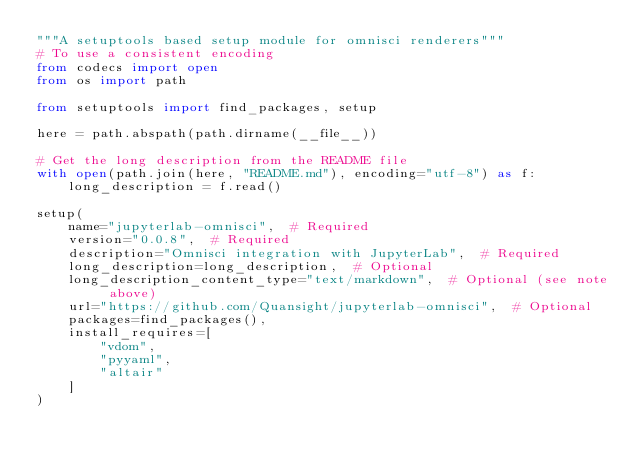Convert code to text. <code><loc_0><loc_0><loc_500><loc_500><_Python_>"""A setuptools based setup module for omnisci renderers"""
# To use a consistent encoding
from codecs import open
from os import path

from setuptools import find_packages, setup

here = path.abspath(path.dirname(__file__))

# Get the long description from the README file
with open(path.join(here, "README.md"), encoding="utf-8") as f:
    long_description = f.read()

setup(
    name="jupyterlab-omnisci",  # Required
    version="0.0.8",  # Required
    description="Omnisci integration with JupyterLab",  # Required
    long_description=long_description,  # Optional
    long_description_content_type="text/markdown",  # Optional (see note above)
    url="https://github.com/Quansight/jupyterlab-omnisci",  # Optional
    packages=find_packages(),
    install_requires=[
        "vdom",
        "pyyaml",
        "altair"
    ]
)
</code> 